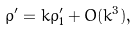Convert formula to latex. <formula><loc_0><loc_0><loc_500><loc_500>\rho ^ { \prime } = k \rho _ { 1 } ^ { \prime } + O ( k ^ { 3 } ) ,</formula> 